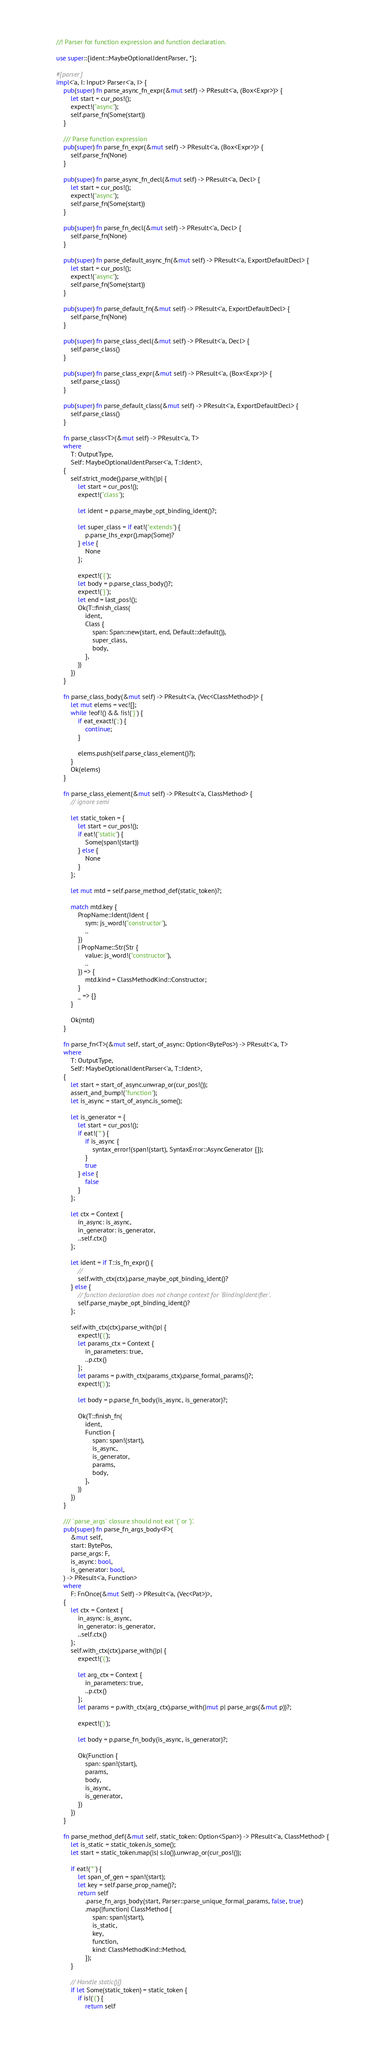Convert code to text. <code><loc_0><loc_0><loc_500><loc_500><_Rust_>//! Parser for function expression and function declaration.

use super::{ident::MaybeOptionalIdentParser, *};

#[parser]
impl<'a, I: Input> Parser<'a, I> {
    pub(super) fn parse_async_fn_expr(&mut self) -> PResult<'a, (Box<Expr>)> {
        let start = cur_pos!();
        expect!("async");
        self.parse_fn(Some(start))
    }

    /// Parse function expression
    pub(super) fn parse_fn_expr(&mut self) -> PResult<'a, (Box<Expr>)> {
        self.parse_fn(None)
    }

    pub(super) fn parse_async_fn_decl(&mut self) -> PResult<'a, Decl> {
        let start = cur_pos!();
        expect!("async");
        self.parse_fn(Some(start))
    }

    pub(super) fn parse_fn_decl(&mut self) -> PResult<'a, Decl> {
        self.parse_fn(None)
    }

    pub(super) fn parse_default_async_fn(&mut self) -> PResult<'a, ExportDefaultDecl> {
        let start = cur_pos!();
        expect!("async");
        self.parse_fn(Some(start))
    }

    pub(super) fn parse_default_fn(&mut self) -> PResult<'a, ExportDefaultDecl> {
        self.parse_fn(None)
    }

    pub(super) fn parse_class_decl(&mut self) -> PResult<'a, Decl> {
        self.parse_class()
    }

    pub(super) fn parse_class_expr(&mut self) -> PResult<'a, (Box<Expr>)> {
        self.parse_class()
    }

    pub(super) fn parse_default_class(&mut self) -> PResult<'a, ExportDefaultDecl> {
        self.parse_class()
    }

    fn parse_class<T>(&mut self) -> PResult<'a, T>
    where
        T: OutputType,
        Self: MaybeOptionalIdentParser<'a, T::Ident>,
    {
        self.strict_mode().parse_with(|p| {
            let start = cur_pos!();
            expect!("class");

            let ident = p.parse_maybe_opt_binding_ident()?;

            let super_class = if eat!("extends") {
                p.parse_lhs_expr().map(Some)?
            } else {
                None
            };

            expect!('{');
            let body = p.parse_class_body()?;
            expect!('}');
            let end = last_pos!();
            Ok(T::finish_class(
                ident,
                Class {
                    span: Span::new(start, end, Default::default()),
                    super_class,
                    body,
                },
            ))
        })
    }

    fn parse_class_body(&mut self) -> PResult<'a, (Vec<ClassMethod>)> {
        let mut elems = vec![];
        while !eof!() && !is!('}') {
            if eat_exact!(';') {
                continue;
            }

            elems.push(self.parse_class_element()?);
        }
        Ok(elems)
    }

    fn parse_class_element(&mut self) -> PResult<'a, ClassMethod> {
        // ignore semi

        let static_token = {
            let start = cur_pos!();
            if eat!("static") {
                Some(span!(start))
            } else {
                None
            }
        };

        let mut mtd = self.parse_method_def(static_token)?;

        match mtd.key {
            PropName::Ident(Ident {
                sym: js_word!("constructor"),
                ..
            })
            | PropName::Str(Str {
                value: js_word!("constructor"),
                ..
            }) => {
                mtd.kind = ClassMethodKind::Constructor;
            }
            _ => {}
        }

        Ok(mtd)
    }

    fn parse_fn<T>(&mut self, start_of_async: Option<BytePos>) -> PResult<'a, T>
    where
        T: OutputType,
        Self: MaybeOptionalIdentParser<'a, T::Ident>,
    {
        let start = start_of_async.unwrap_or(cur_pos!());
        assert_and_bump!("function");
        let is_async = start_of_async.is_some();

        let is_generator = {
            let start = cur_pos!();
            if eat!('*') {
                if is_async {
                    syntax_error!(span!(start), SyntaxError::AsyncGenerator {});
                }
                true
            } else {
                false
            }
        };

        let ctx = Context {
            in_async: is_async,
            in_generator: is_generator,
            ..self.ctx()
        };

        let ident = if T::is_fn_expr() {
            //
            self.with_ctx(ctx).parse_maybe_opt_binding_ident()?
        } else {
            // function declaration does not change context for `BindingIdentifier`.
            self.parse_maybe_opt_binding_ident()?
        };

        self.with_ctx(ctx).parse_with(|p| {
            expect!('(');
            let params_ctx = Context {
                in_parameters: true,
                ..p.ctx()
            };
            let params = p.with_ctx(params_ctx).parse_formal_params()?;
            expect!(')');

            let body = p.parse_fn_body(is_async, is_generator)?;

            Ok(T::finish_fn(
                ident,
                Function {
                    span: span!(start),
                    is_async,
                    is_generator,
                    params,
                    body,
                },
            ))
        })
    }

    /// `parse_args` closure should not eat '(' or ')'.
    pub(super) fn parse_fn_args_body<F>(
        &mut self,
        start: BytePos,
        parse_args: F,
        is_async: bool,
        is_generator: bool,
    ) -> PResult<'a, Function>
    where
        F: FnOnce(&mut Self) -> PResult<'a, (Vec<Pat>)>,
    {
        let ctx = Context {
            in_async: is_async,
            in_generator: is_generator,
            ..self.ctx()
        };
        self.with_ctx(ctx).parse_with(|p| {
            expect!('(');

            let arg_ctx = Context {
                in_parameters: true,
                ..p.ctx()
            };
            let params = p.with_ctx(arg_ctx).parse_with(|mut p| parse_args(&mut p))?;

            expect!(')');

            let body = p.parse_fn_body(is_async, is_generator)?;

            Ok(Function {
                span: span!(start),
                params,
                body,
                is_async,
                is_generator,
            })
        })
    }

    fn parse_method_def(&mut self, static_token: Option<Span>) -> PResult<'a, ClassMethod> {
        let is_static = static_token.is_some();
        let start = static_token.map(|s| s.lo()).unwrap_or(cur_pos!());

        if eat!('*') {
            let span_of_gen = span!(start);
            let key = self.parse_prop_name()?;
            return self
                .parse_fn_args_body(start, Parser::parse_unique_formal_params, false, true)
                .map(|function| ClassMethod {
                    span: span!(start),
                    is_static,
                    key,
                    function,
                    kind: ClassMethodKind::Method,
                });
        }

        // Handle static(){}
        if let Some(static_token) = static_token {
            if is!('(') {
                return self</code> 